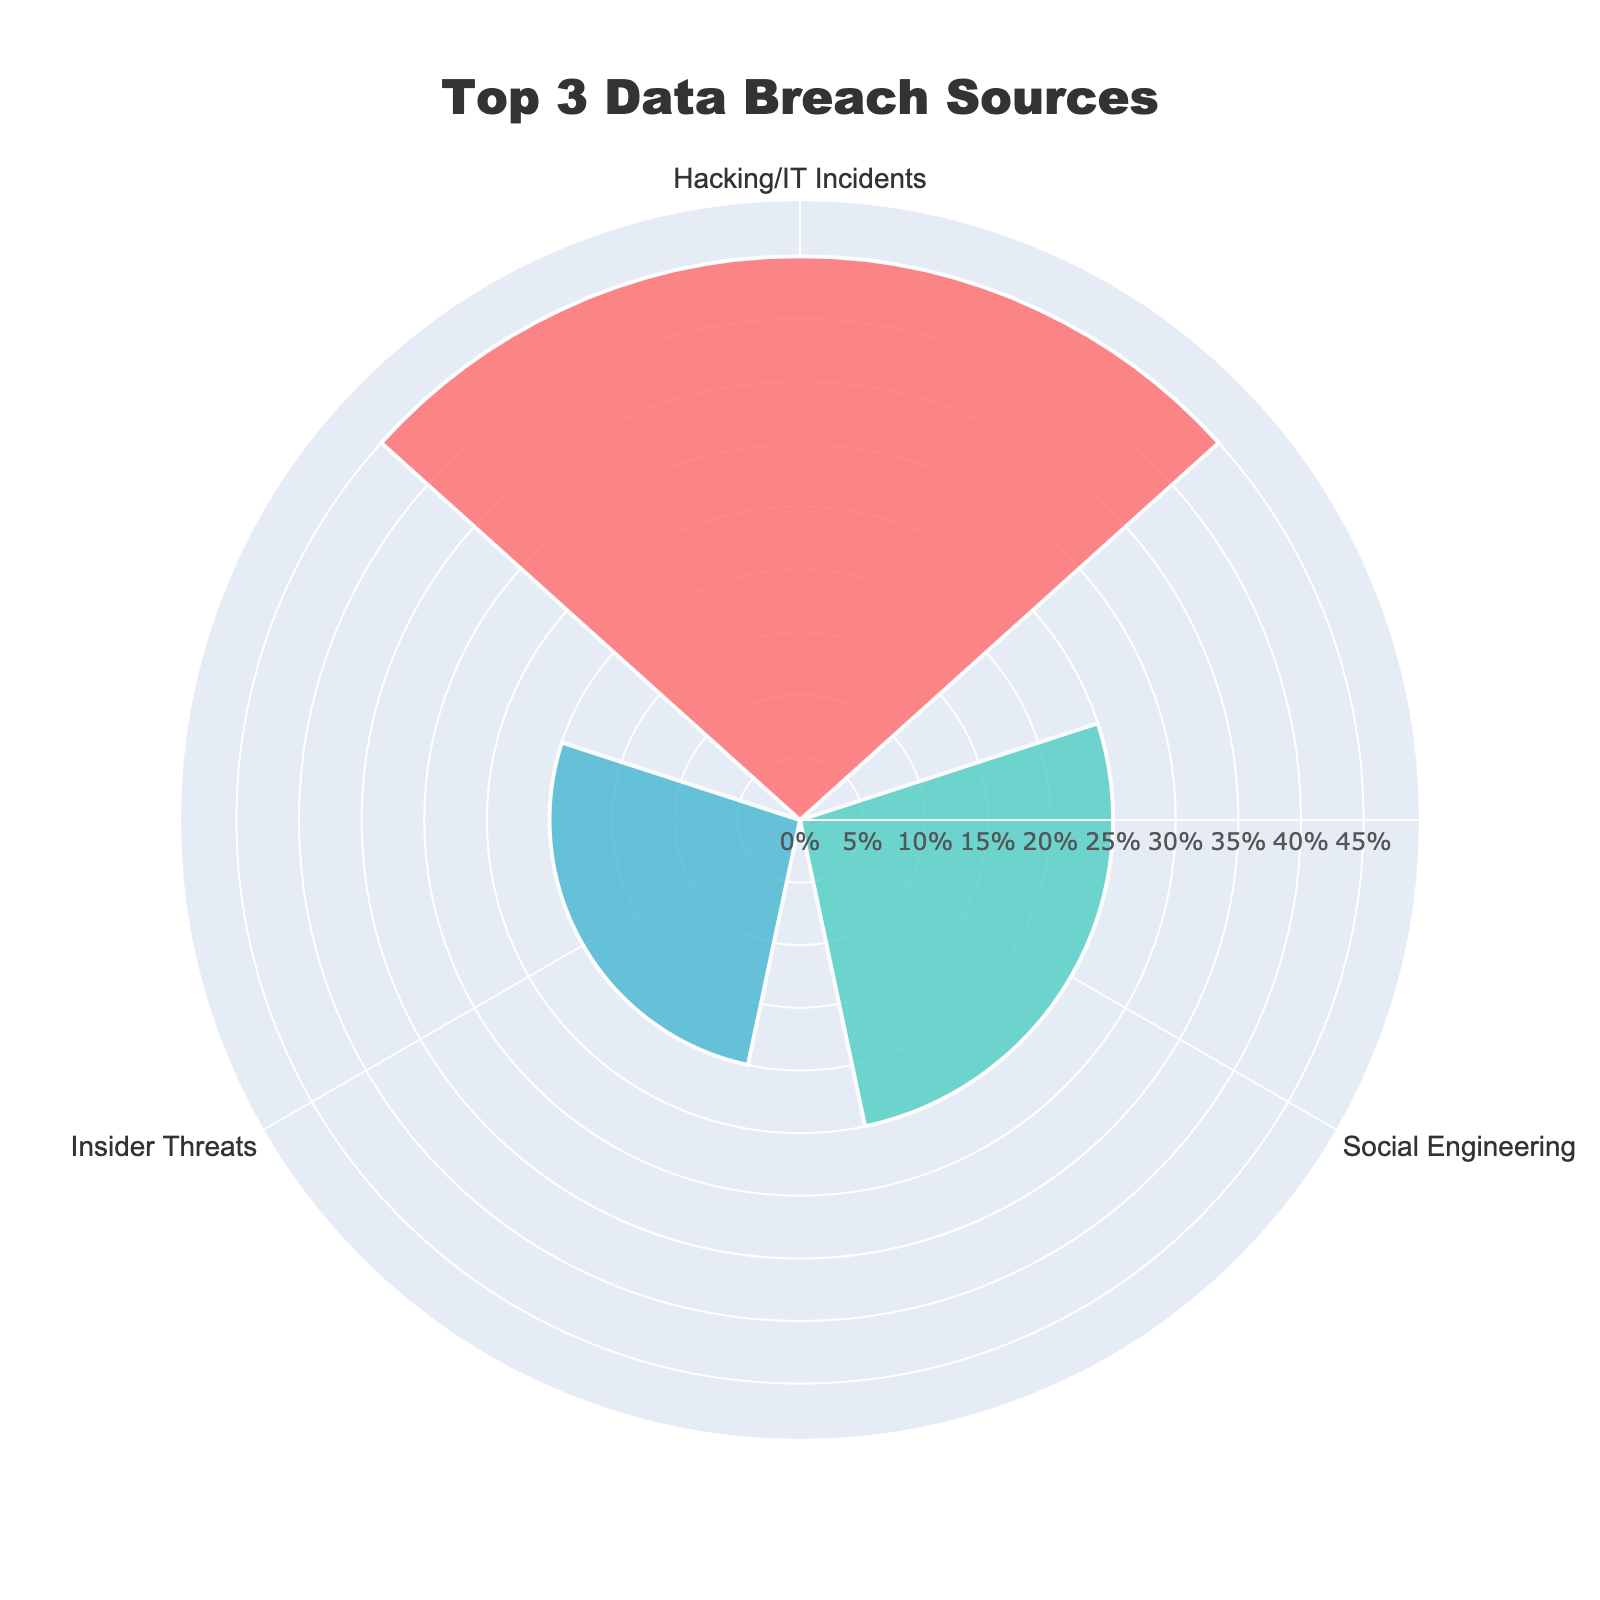What is the title of the chart? The title is displayed prominently at the top of the chart within the layout. It reads "Top 3 Data Breach Sources."
Answer: Top 3 Data Breach Sources What are the three categories shown in the rose chart? The three categories are readily visible along the polar axis of the chart. They are labeled as "Hacking/IT Incidents," "Social Engineering," and "Insider Threats."
Answer: Hacking/IT Incidents, Social Engineering, Insider Threats Which category has the highest percentage? By examining the lengths of the bars, we can see that "Hacking/IT Incidents" has the longest bar, indicating the highest percentage.
Answer: Hacking/IT Incidents What percentage does the 'Social Engineering' category represent? The percentage values are displayed within the chart. The bar corresponding to "Social Engineering" shows 25%.
Answer: 25% How many more percentage points does "Hacking/IT Incidents" have compared to "Insider Threats"? "Hacking/IT Incidents" has 45%, and "Insider Threats" has 20%. The difference is calculated as 45% - 20% = 25%.
Answer: 25% Which color is used to represent "Insider Threats"? The colors are visually distinguishable, and the bar labeled "Insider Threats" is shown in a blue color.
Answer: Blue Which two categories combined make up more than half of the total incidents? Adding the percentages of the categories: "Hacking/IT Incidents" (45%) + "Social Engineering" (25%) = 70%. Since 70% is more than half (50%), these two categories together make up more than half of the total incidents.
Answer: Hacking/IT Incidents and Social Engineering What is the approximate average percentage of the top 3 categories? Sum the percentages of the three categories: (45 + 25 + 20) = 90. Then divide by the number of categories: 90 / 3 = 30.
Answer: 30 Out of the top 3 categories, which one contributes the least to data breaches? The bar corresponding to "Insider Threats" is the shortest, indicating it has the lowest percentage.
Answer: Insider Threats Is the radial axis visible in the rose chart, and what range does it cover? The radial axis is visible as shown in the chart. It ranges from 0 to slightly above the maximum percentage, which is 45%. The maximum range is displayed as 49.5 (45 * 1.1).
Answer: Yes, 0 to 49.5 